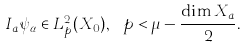<formula> <loc_0><loc_0><loc_500><loc_500>I _ { a } \psi _ { \alpha } \in L ^ { 2 } _ { p } ( X _ { 0 } ) , \ p < \mu - \frac { \dim X _ { a } } { 2 } .</formula> 